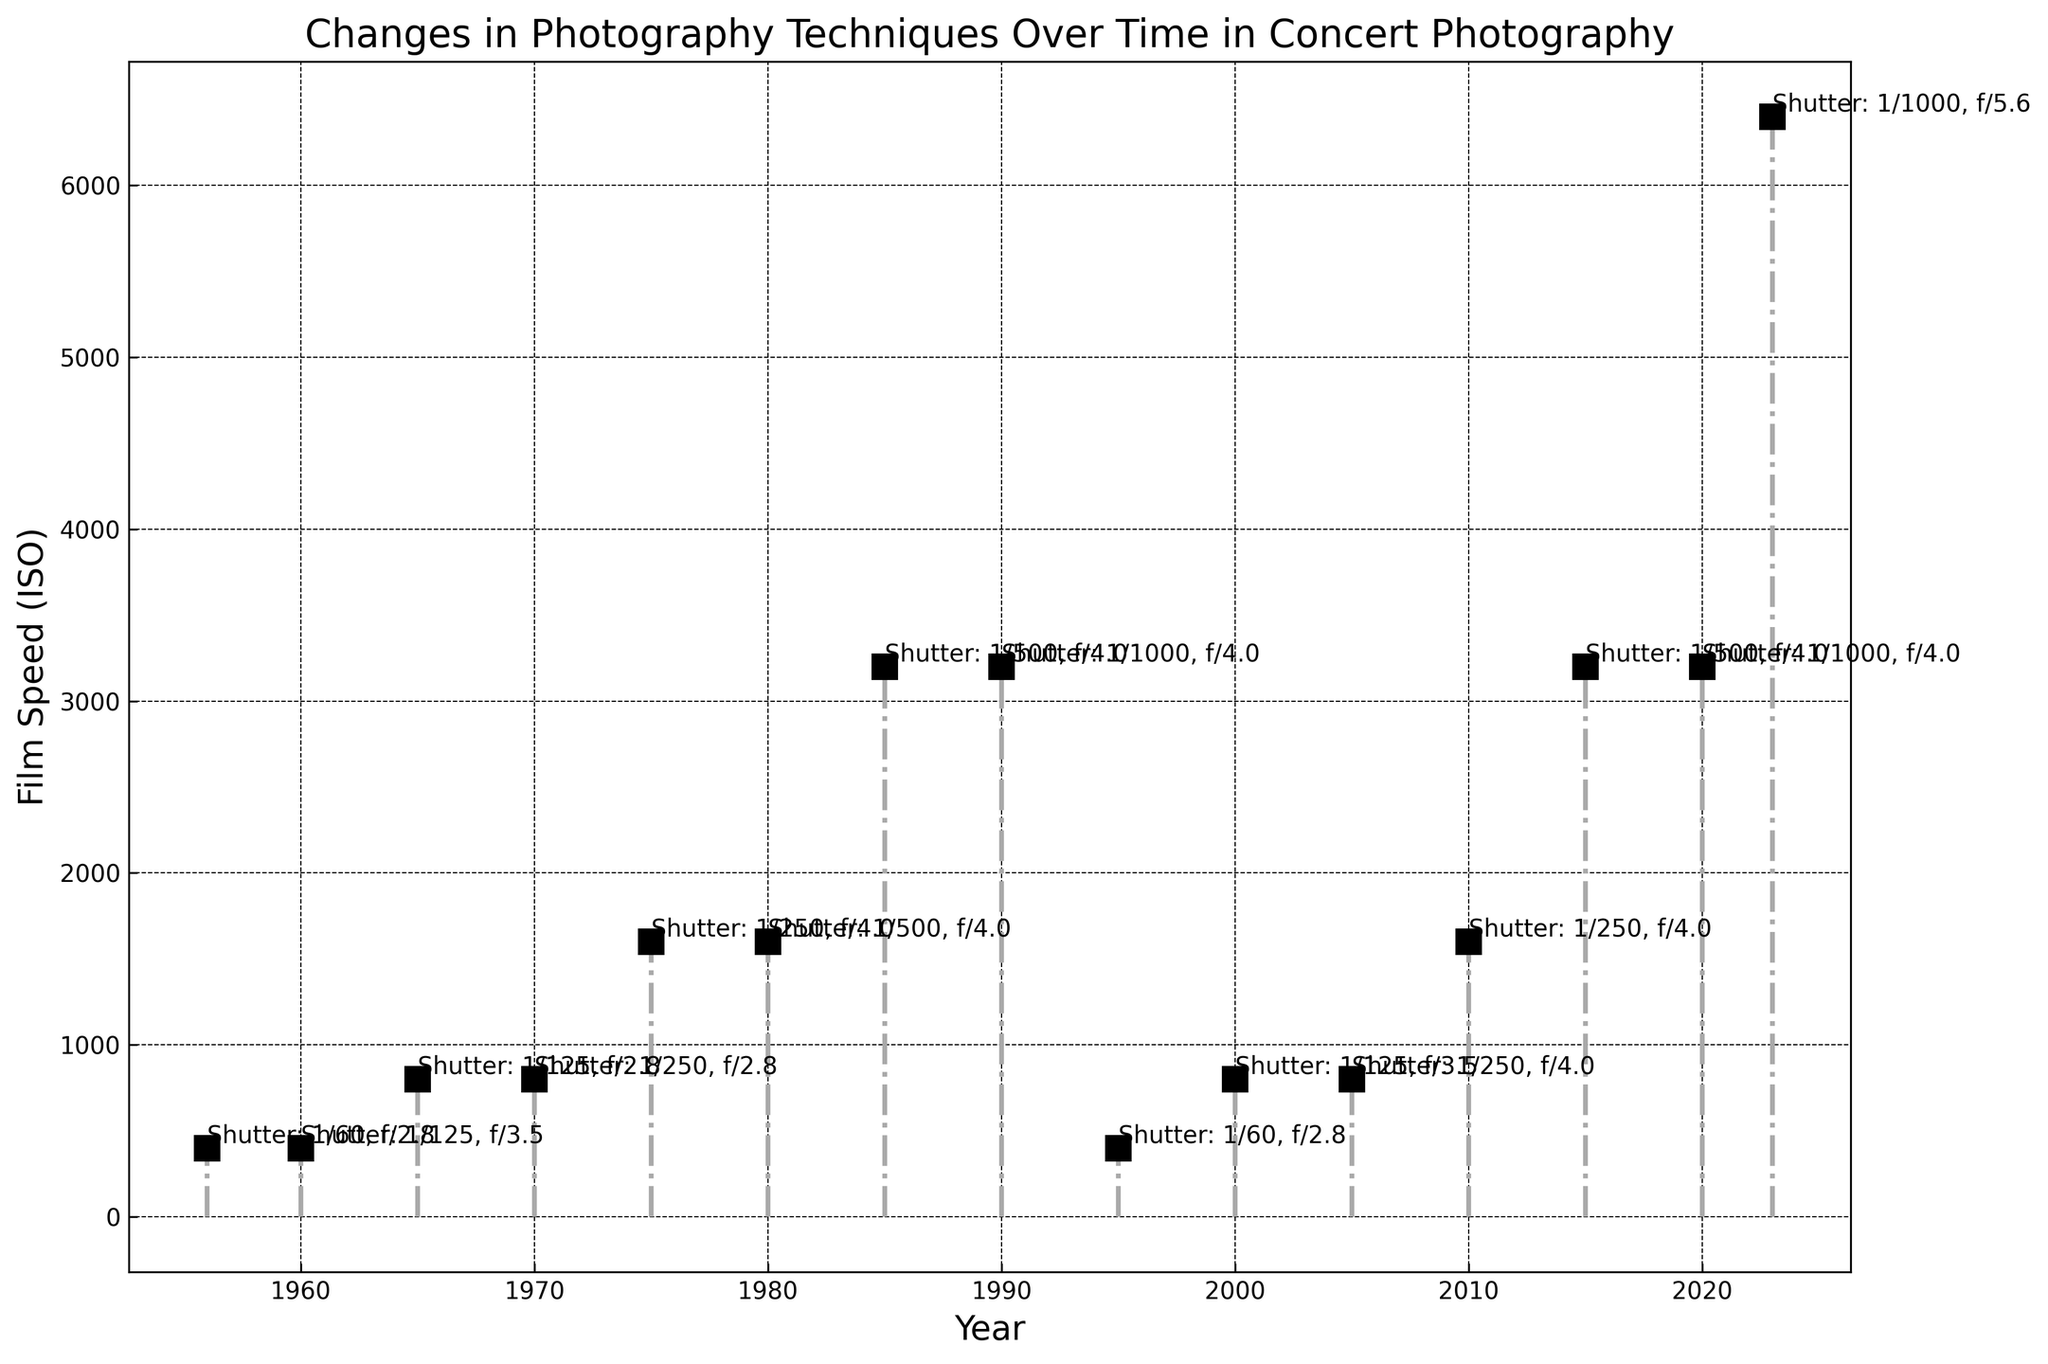What is the lowest film speed (ISO) used in the 1960s? The 1960s include the years 1960 and 1965. Check the film speeds for these years: 1960 uses ISO 400 and 1965 uses ISO 800. The lowest film speed in the 1960s is ISO 400.
Answer: 400 How did the shutter speed change from 1980 to 1985? Compare the shutter speeds for the years 1980 (1/500) and 1985 (1/500). The shutter speed remained the same, staying at 1/500 from 1980 to 1985.
Answer: It remained the same What is the overall trend in film speed (ISO) from 1956 to 2023? Film speed gradually increases from ISO 400 in 1956 to ISO 6400 in 2023. It shows a clear upward trend.
Answer: Increasing Which year had the highest film speed (ISO)? Check the stem plot to find the topmost point along the y-axis (ISO levels). The year 2023 has the highest film speed at ISO 6400.
Answer: 2023 What were the aperture settings for the years with ISO 1600? ISO 1600 years are 1975, 1980, and 2010. The aperture settings for these years are f/4, f/4, and f/4, respectively.
Answer: f/4 In which year do you see the shift to multi-color spotlights? Multi-color spotlights first appear in 1985, as noted via a visual marker and annotation in the plot.
Answer: 1985 What is the difference in film speed between 1990 and 2023? Subtract the film speed of 1990 (3200) from that of 2023 (6400) to find the difference. 6400 - 3200 = 3200.
Answer: 3200 What does the annotation "Shutter: 1/500, f/4" refer to, in the context of the plot? The annotation specifies the shutter speed and aperture for a specific year. By examining the plot, this combination is notable for the years such as 1985 and 1980.
Answer: Shutter speed and aperture for 1980 and 1985 Which year had a significant increase in film speed after a period of consistency? ISO remains consistent at 3200 between 1990 and 2015, then jumps to 6400 in 2023.
Answer: 2023 How does the film speed change between the years 1995 and 2000? Compare the film speeds for 1995 (400) and 2000 (800). There is an increase from ISO 400 to ISO 800.
Answer: Increased 